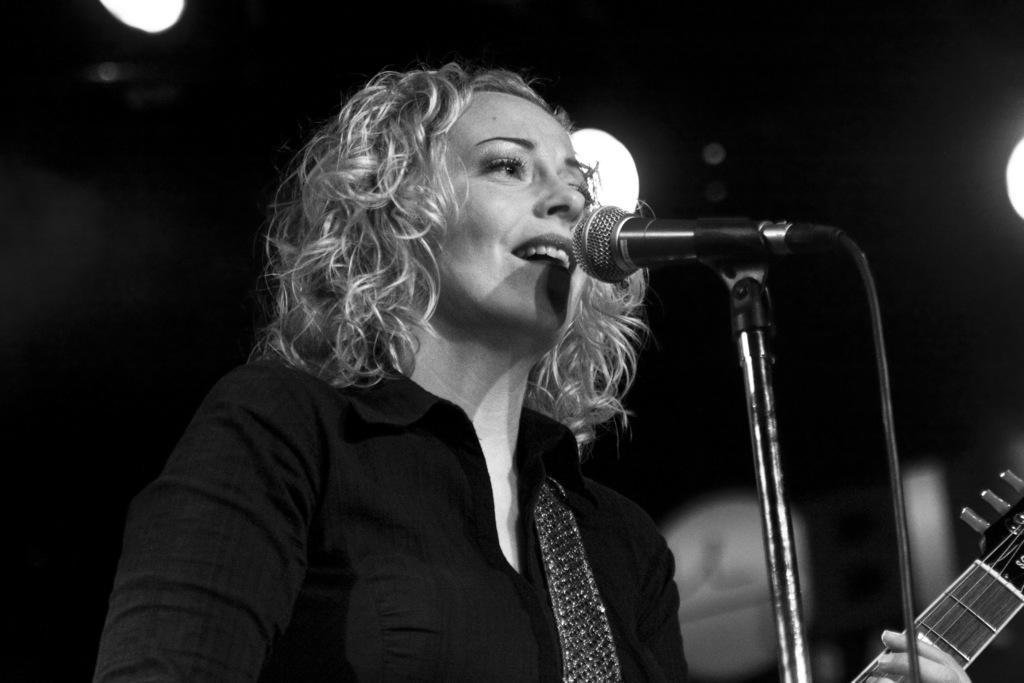Describe this image in one or two sentences. A woman is singing with a mic in front her while playing a guitar. 